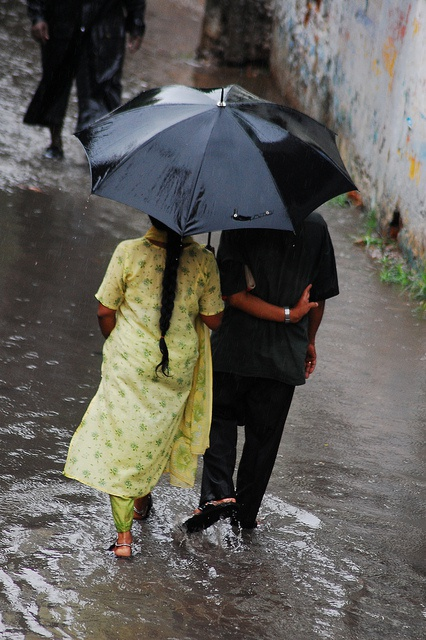Describe the objects in this image and their specific colors. I can see people in black, olive, and beige tones, umbrella in black, gray, darkblue, and darkgray tones, people in black, maroon, and gray tones, and people in black and gray tones in this image. 